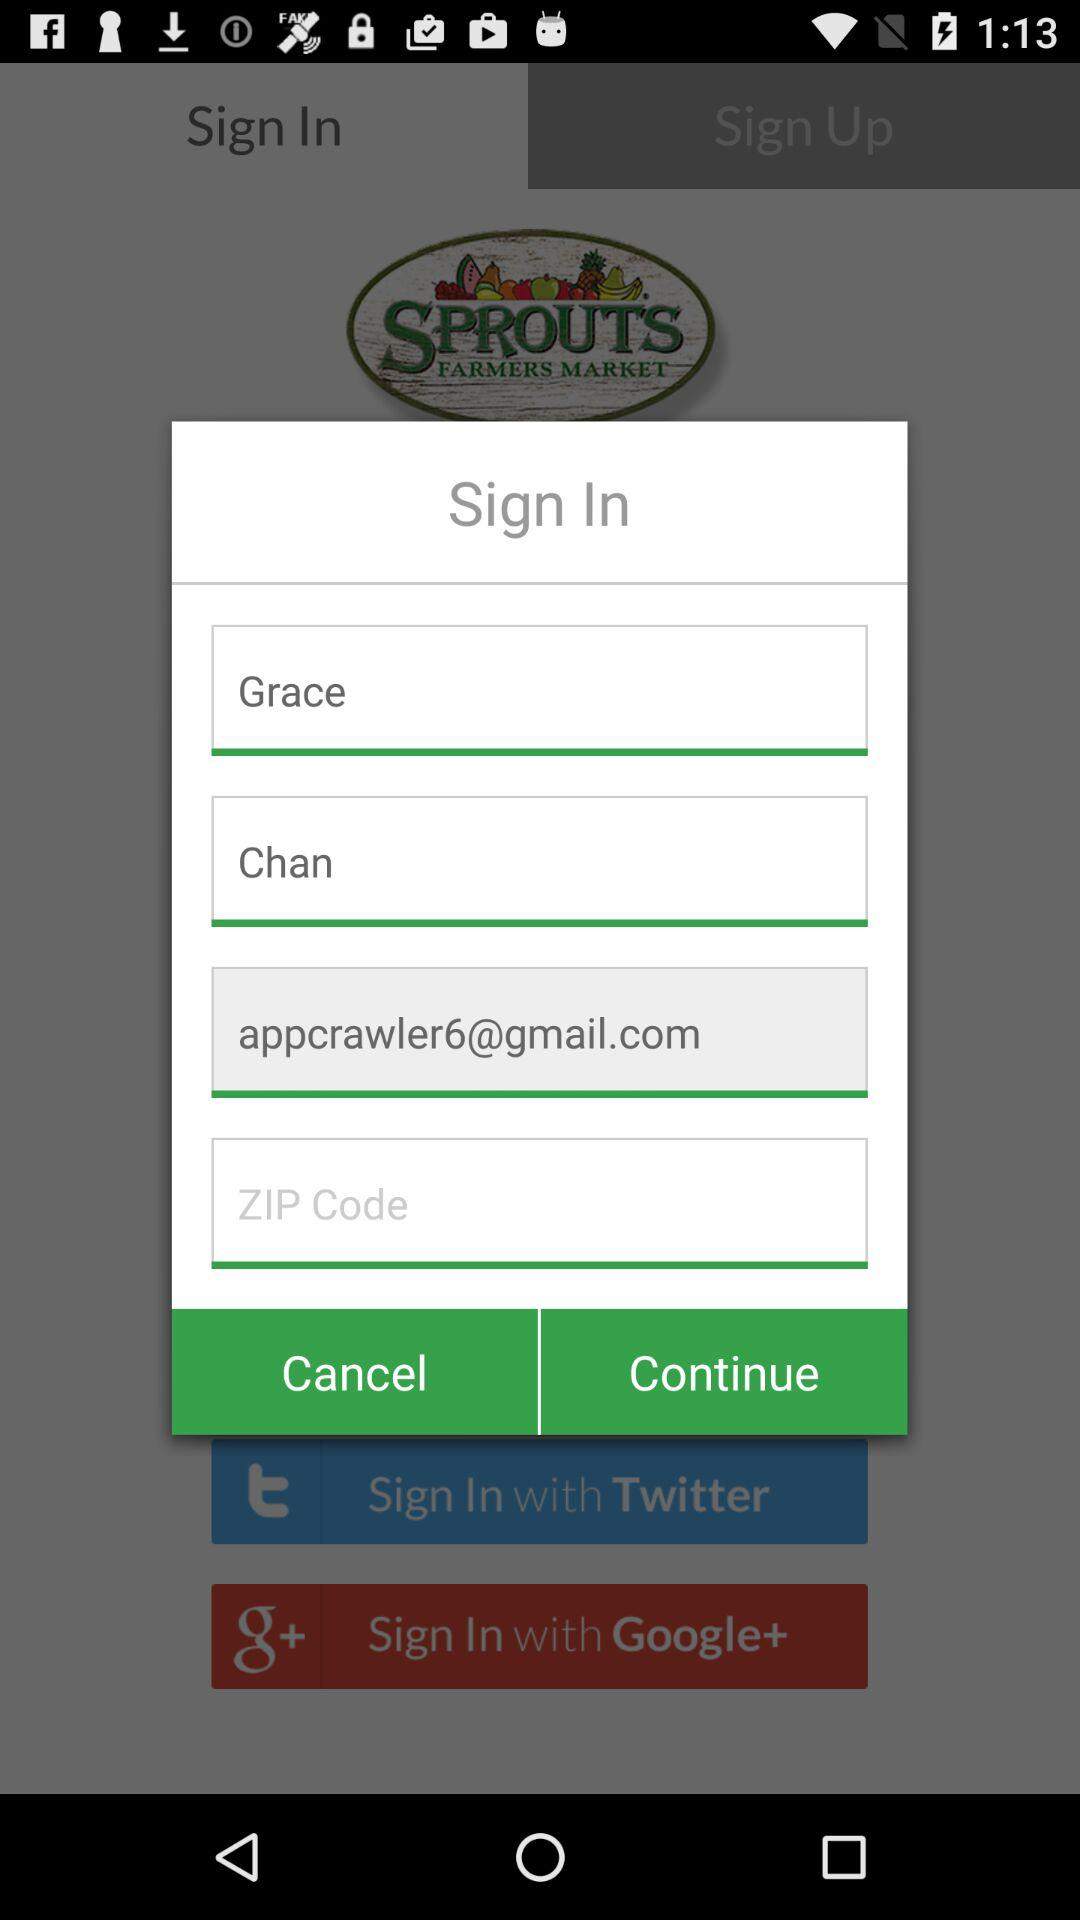What is the name of the application? The name of the application is "Sprouts". 